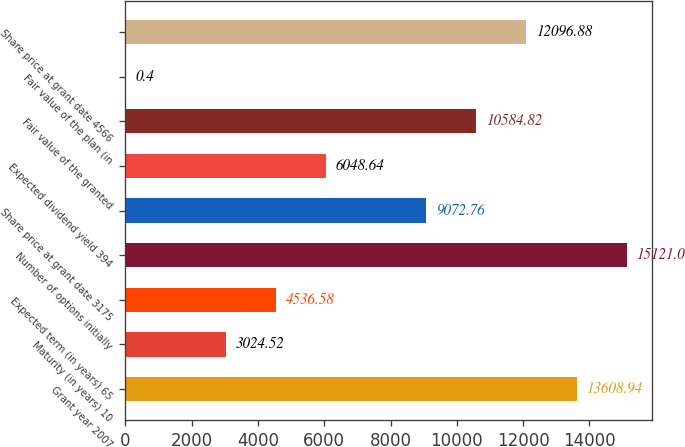Convert chart. <chart><loc_0><loc_0><loc_500><loc_500><bar_chart><fcel>Grant year 2007<fcel>Maturity (in years) 10<fcel>Expected term (in years) 65<fcel>Number of options initially<fcel>Share price at grant date 3175<fcel>Expected dividend yield 394<fcel>Fair value of the granted<fcel>Fair value of the plan (in<fcel>Share price at grant date 4566<nl><fcel>13608.9<fcel>3024.52<fcel>4536.58<fcel>15121<fcel>9072.76<fcel>6048.64<fcel>10584.8<fcel>0.4<fcel>12096.9<nl></chart> 